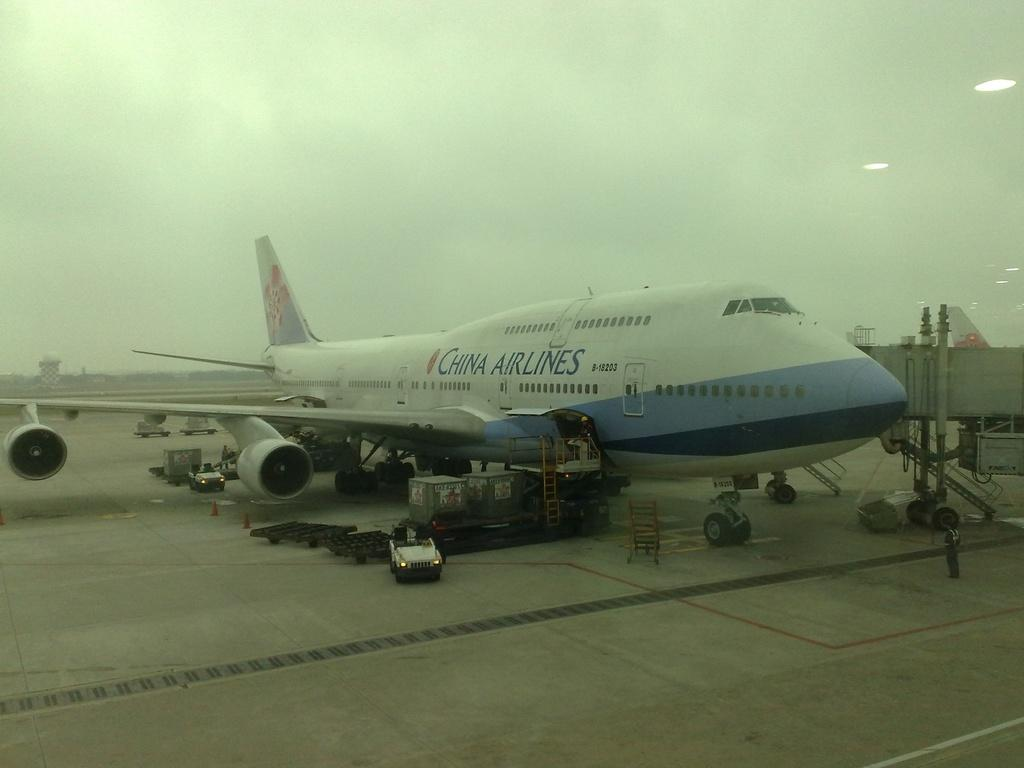<image>
Give a short and clear explanation of the subsequent image. A China Airlines 747 at the airport next to the terminal. 